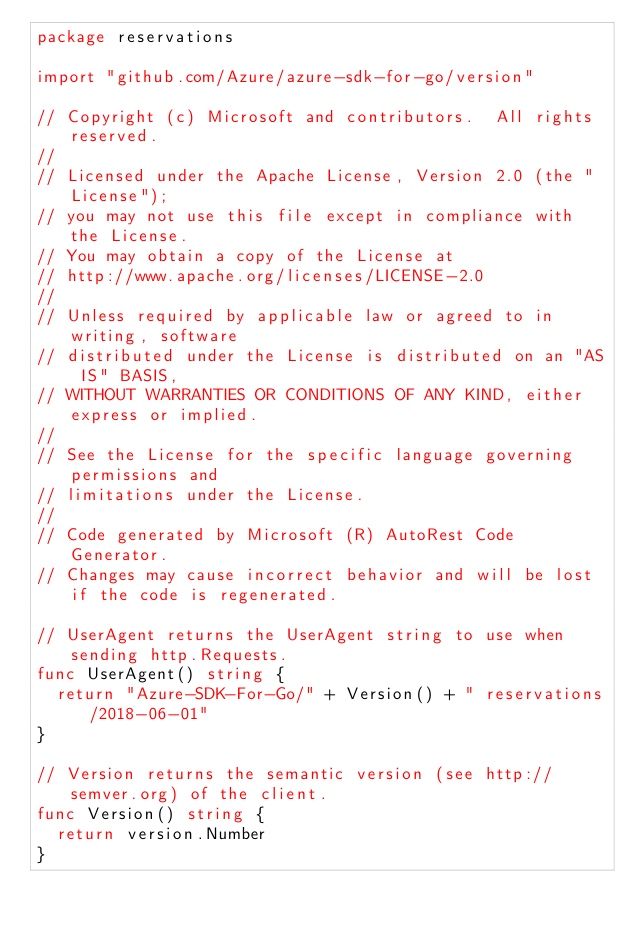Convert code to text. <code><loc_0><loc_0><loc_500><loc_500><_Go_>package reservations

import "github.com/Azure/azure-sdk-for-go/version"

// Copyright (c) Microsoft and contributors.  All rights reserved.
//
// Licensed under the Apache License, Version 2.0 (the "License");
// you may not use this file except in compliance with the License.
// You may obtain a copy of the License at
// http://www.apache.org/licenses/LICENSE-2.0
//
// Unless required by applicable law or agreed to in writing, software
// distributed under the License is distributed on an "AS IS" BASIS,
// WITHOUT WARRANTIES OR CONDITIONS OF ANY KIND, either express or implied.
//
// See the License for the specific language governing permissions and
// limitations under the License.
//
// Code generated by Microsoft (R) AutoRest Code Generator.
// Changes may cause incorrect behavior and will be lost if the code is regenerated.

// UserAgent returns the UserAgent string to use when sending http.Requests.
func UserAgent() string {
	return "Azure-SDK-For-Go/" + Version() + " reservations/2018-06-01"
}

// Version returns the semantic version (see http://semver.org) of the client.
func Version() string {
	return version.Number
}
</code> 